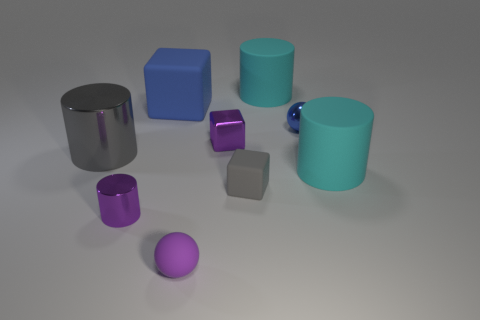Subtract 1 cylinders. How many cylinders are left? 3 Subtract all cubes. How many objects are left? 6 Add 7 metallic cylinders. How many metallic cylinders exist? 9 Subtract 2 cyan cylinders. How many objects are left? 7 Subtract all tiny blue objects. Subtract all blue spheres. How many objects are left? 7 Add 4 tiny blue metal objects. How many tiny blue metal objects are left? 5 